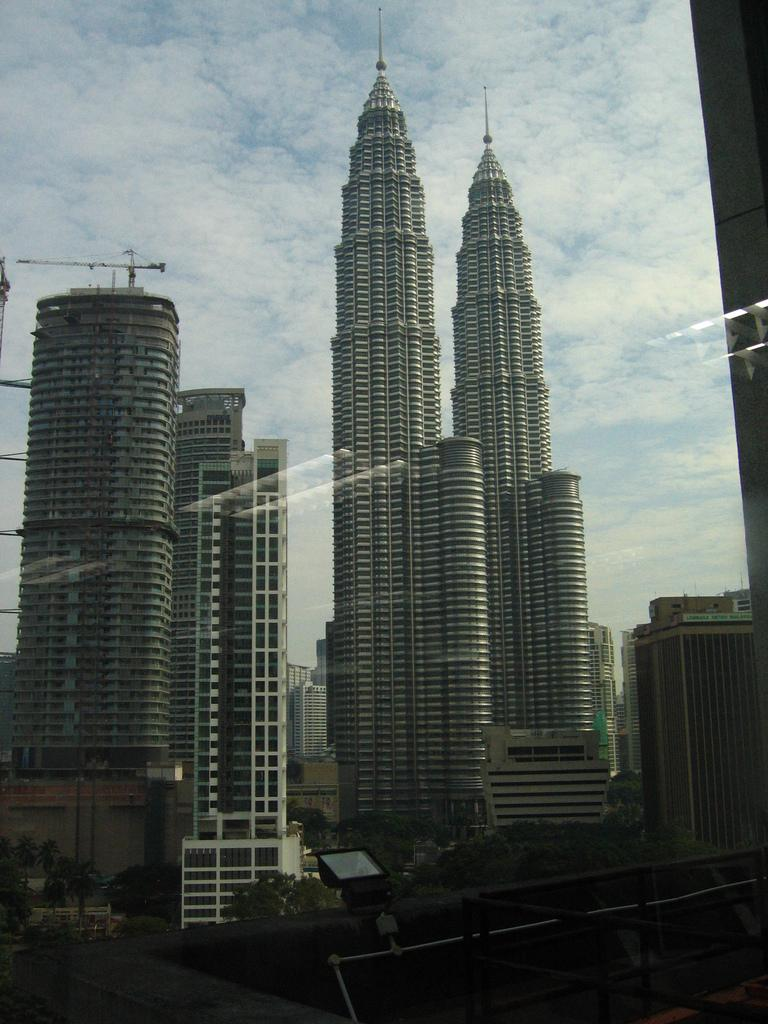What type of structures are visible in the image? There are buildings in the image. Can you describe a specific feature of the buildings? There is a light on the wall in the image. Where is the light located in relation to the image? The light is at the bottom of the image. What can be seen in the sky in the image? There are clouds in the sky in the image. How many balls are being juggled by the beginner in the image? There are no balls or beginners present in the image; it features buildings, a light, and clouds. 